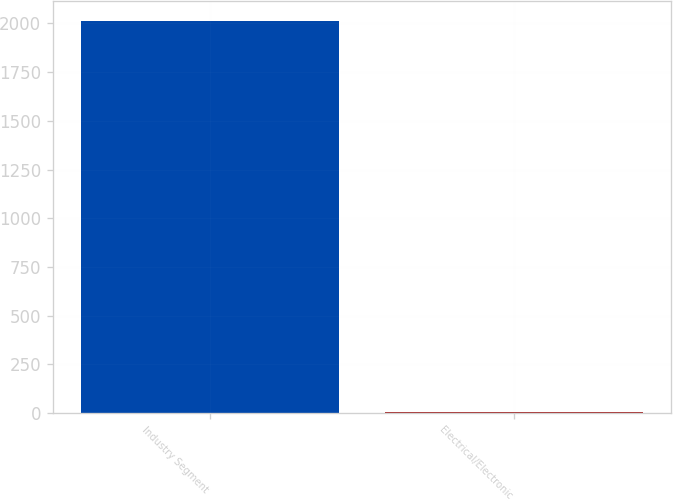<chart> <loc_0><loc_0><loc_500><loc_500><bar_chart><fcel>Industry Segment<fcel>Electrical/Electronic<nl><fcel>2014<fcel>5<nl></chart> 